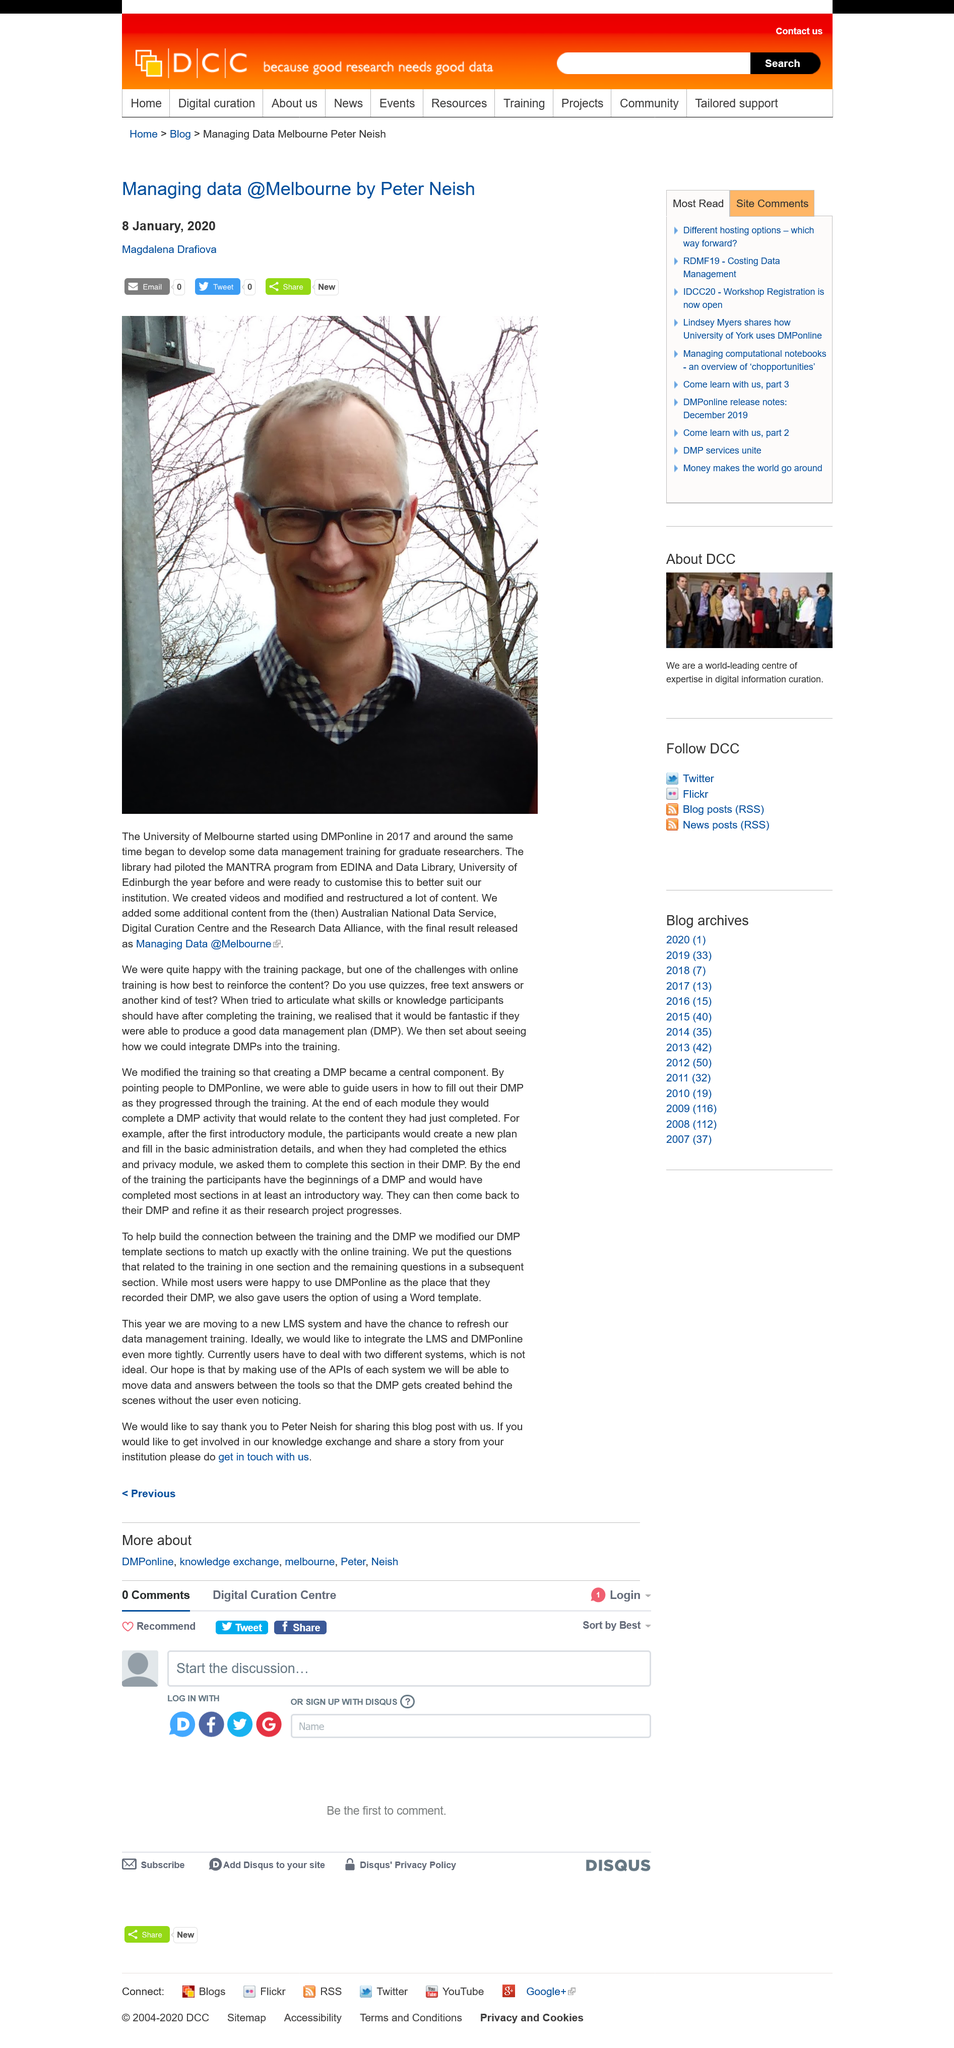Highlight a few significant elements in this photo. The University of Melbourne integrated data management plans into their training to reinforce the content. Peter Neish works for Melbourne University. The University of Melbourne started using DMPonline in 2017. 